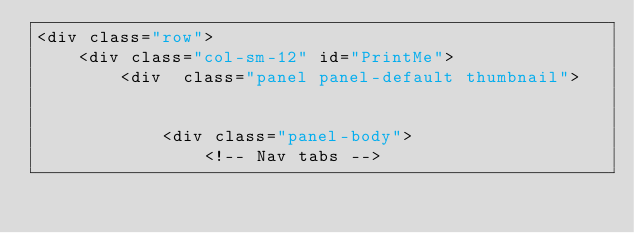Convert code to text. <code><loc_0><loc_0><loc_500><loc_500><_PHP_><div class="row">
    <div class="col-sm-12" id="PrintMe">
        <div  class="panel panel-default thumbnail">
  

            <div class="panel-body"> 
                <!-- Nav tabs --> </code> 